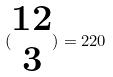<formula> <loc_0><loc_0><loc_500><loc_500>( \begin{matrix} 1 2 \\ 3 \end{matrix} ) = 2 2 0</formula> 